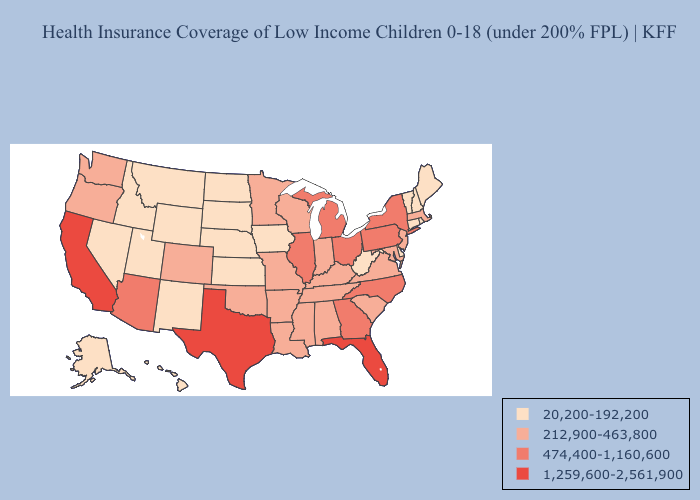Which states have the lowest value in the Northeast?
Short answer required. Connecticut, Maine, New Hampshire, Rhode Island, Vermont. Among the states that border Nevada , which have the lowest value?
Quick response, please. Idaho, Utah. What is the lowest value in states that border South Dakota?
Answer briefly. 20,200-192,200. Does Oregon have the same value as West Virginia?
Quick response, please. No. Does Alabama have the highest value in the USA?
Quick response, please. No. What is the lowest value in states that border New Hampshire?
Quick response, please. 20,200-192,200. Which states have the highest value in the USA?
Be succinct. California, Florida, Texas. Does the map have missing data?
Write a very short answer. No. Does Maine have the lowest value in the Northeast?
Quick response, please. Yes. What is the value of Wyoming?
Give a very brief answer. 20,200-192,200. What is the highest value in the USA?
Quick response, please. 1,259,600-2,561,900. Name the states that have a value in the range 212,900-463,800?
Write a very short answer. Alabama, Arkansas, Colorado, Indiana, Kentucky, Louisiana, Maryland, Massachusetts, Minnesota, Mississippi, Missouri, New Jersey, Oklahoma, Oregon, South Carolina, Tennessee, Virginia, Washington, Wisconsin. Among the states that border South Dakota , does Minnesota have the highest value?
Be succinct. Yes. Name the states that have a value in the range 20,200-192,200?
Concise answer only. Alaska, Connecticut, Delaware, Hawaii, Idaho, Iowa, Kansas, Maine, Montana, Nebraska, Nevada, New Hampshire, New Mexico, North Dakota, Rhode Island, South Dakota, Utah, Vermont, West Virginia, Wyoming. Name the states that have a value in the range 20,200-192,200?
Concise answer only. Alaska, Connecticut, Delaware, Hawaii, Idaho, Iowa, Kansas, Maine, Montana, Nebraska, Nevada, New Hampshire, New Mexico, North Dakota, Rhode Island, South Dakota, Utah, Vermont, West Virginia, Wyoming. 